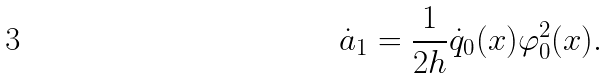Convert formula to latex. <formula><loc_0><loc_0><loc_500><loc_500>\dot { a } _ { 1 } = \frac { 1 } { 2 h } \dot { q } _ { 0 } ( x ) \varphi _ { 0 } ^ { 2 } ( x ) .</formula> 